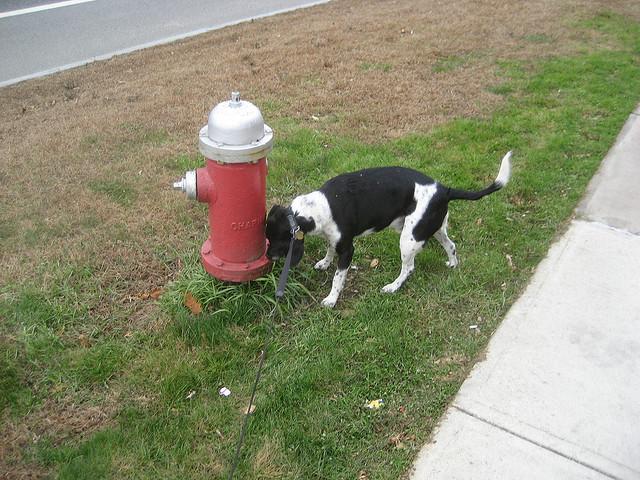Is the dog on a leash?
Be succinct. Yes. What is the dog carrying?
Quick response, please. Nothing. What color is the tip of the animal's tail?
Concise answer only. White. What breed is the dog?
Keep it brief. Terrier. 